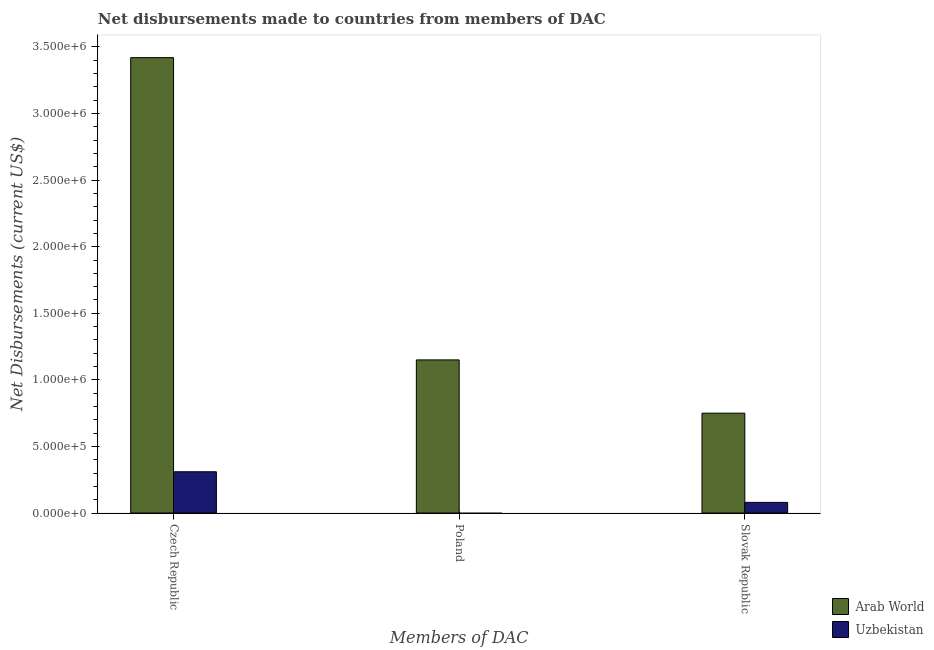How many different coloured bars are there?
Your response must be concise. 2. Are the number of bars on each tick of the X-axis equal?
Offer a terse response. No. What is the label of the 2nd group of bars from the left?
Your answer should be very brief. Poland. What is the net disbursements made by poland in Arab World?
Make the answer very short. 1.15e+06. Across all countries, what is the maximum net disbursements made by poland?
Provide a succinct answer. 1.15e+06. Across all countries, what is the minimum net disbursements made by slovak republic?
Provide a succinct answer. 8.00e+04. In which country was the net disbursements made by slovak republic maximum?
Your response must be concise. Arab World. What is the total net disbursements made by poland in the graph?
Make the answer very short. 1.15e+06. What is the difference between the net disbursements made by czech republic in Arab World and that in Uzbekistan?
Your response must be concise. 3.11e+06. What is the difference between the net disbursements made by slovak republic in Uzbekistan and the net disbursements made by czech republic in Arab World?
Provide a short and direct response. -3.34e+06. What is the average net disbursements made by slovak republic per country?
Provide a succinct answer. 4.15e+05. What is the difference between the net disbursements made by slovak republic and net disbursements made by poland in Arab World?
Provide a short and direct response. -4.00e+05. What is the ratio of the net disbursements made by czech republic in Arab World to that in Uzbekistan?
Your response must be concise. 11.03. What is the difference between the highest and the second highest net disbursements made by czech republic?
Offer a very short reply. 3.11e+06. What is the difference between the highest and the lowest net disbursements made by poland?
Make the answer very short. 1.15e+06. Is it the case that in every country, the sum of the net disbursements made by czech republic and net disbursements made by poland is greater than the net disbursements made by slovak republic?
Give a very brief answer. Yes. How many countries are there in the graph?
Your response must be concise. 2. Are the values on the major ticks of Y-axis written in scientific E-notation?
Give a very brief answer. Yes. Does the graph contain any zero values?
Provide a short and direct response. Yes. Does the graph contain grids?
Offer a terse response. No. How are the legend labels stacked?
Ensure brevity in your answer.  Vertical. What is the title of the graph?
Your answer should be compact. Net disbursements made to countries from members of DAC. What is the label or title of the X-axis?
Provide a succinct answer. Members of DAC. What is the label or title of the Y-axis?
Your answer should be very brief. Net Disbursements (current US$). What is the Net Disbursements (current US$) of Arab World in Czech Republic?
Provide a short and direct response. 3.42e+06. What is the Net Disbursements (current US$) in Uzbekistan in Czech Republic?
Give a very brief answer. 3.10e+05. What is the Net Disbursements (current US$) in Arab World in Poland?
Your response must be concise. 1.15e+06. What is the Net Disbursements (current US$) in Arab World in Slovak Republic?
Provide a succinct answer. 7.50e+05. What is the Net Disbursements (current US$) in Uzbekistan in Slovak Republic?
Your answer should be very brief. 8.00e+04. Across all Members of DAC, what is the maximum Net Disbursements (current US$) in Arab World?
Provide a succinct answer. 3.42e+06. Across all Members of DAC, what is the maximum Net Disbursements (current US$) of Uzbekistan?
Offer a very short reply. 3.10e+05. Across all Members of DAC, what is the minimum Net Disbursements (current US$) in Arab World?
Ensure brevity in your answer.  7.50e+05. Across all Members of DAC, what is the minimum Net Disbursements (current US$) of Uzbekistan?
Your response must be concise. 0. What is the total Net Disbursements (current US$) in Arab World in the graph?
Your response must be concise. 5.32e+06. What is the difference between the Net Disbursements (current US$) in Arab World in Czech Republic and that in Poland?
Make the answer very short. 2.27e+06. What is the difference between the Net Disbursements (current US$) in Arab World in Czech Republic and that in Slovak Republic?
Your response must be concise. 2.67e+06. What is the difference between the Net Disbursements (current US$) in Arab World in Poland and that in Slovak Republic?
Give a very brief answer. 4.00e+05. What is the difference between the Net Disbursements (current US$) of Arab World in Czech Republic and the Net Disbursements (current US$) of Uzbekistan in Slovak Republic?
Your answer should be compact. 3.34e+06. What is the difference between the Net Disbursements (current US$) of Arab World in Poland and the Net Disbursements (current US$) of Uzbekistan in Slovak Republic?
Provide a succinct answer. 1.07e+06. What is the average Net Disbursements (current US$) in Arab World per Members of DAC?
Offer a terse response. 1.77e+06. What is the difference between the Net Disbursements (current US$) of Arab World and Net Disbursements (current US$) of Uzbekistan in Czech Republic?
Ensure brevity in your answer.  3.11e+06. What is the difference between the Net Disbursements (current US$) in Arab World and Net Disbursements (current US$) in Uzbekistan in Slovak Republic?
Give a very brief answer. 6.70e+05. What is the ratio of the Net Disbursements (current US$) of Arab World in Czech Republic to that in Poland?
Offer a very short reply. 2.97. What is the ratio of the Net Disbursements (current US$) in Arab World in Czech Republic to that in Slovak Republic?
Keep it short and to the point. 4.56. What is the ratio of the Net Disbursements (current US$) of Uzbekistan in Czech Republic to that in Slovak Republic?
Offer a very short reply. 3.88. What is the ratio of the Net Disbursements (current US$) in Arab World in Poland to that in Slovak Republic?
Give a very brief answer. 1.53. What is the difference between the highest and the second highest Net Disbursements (current US$) in Arab World?
Ensure brevity in your answer.  2.27e+06. What is the difference between the highest and the lowest Net Disbursements (current US$) in Arab World?
Keep it short and to the point. 2.67e+06. 